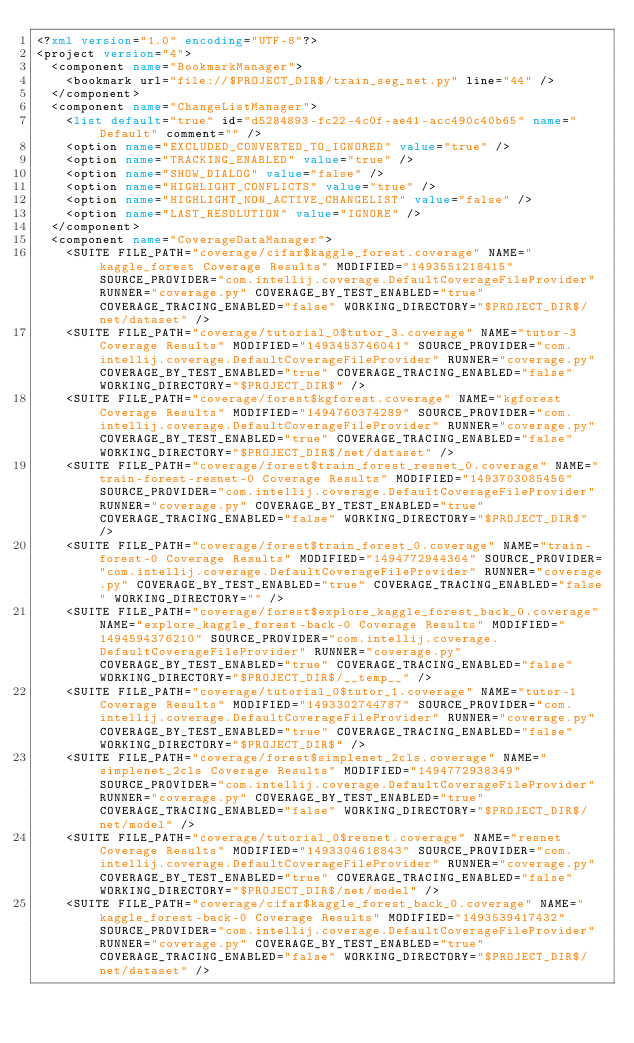<code> <loc_0><loc_0><loc_500><loc_500><_XML_><?xml version="1.0" encoding="UTF-8"?>
<project version="4">
  <component name="BookmarkManager">
    <bookmark url="file://$PROJECT_DIR$/train_seg_net.py" line="44" />
  </component>
  <component name="ChangeListManager">
    <list default="true" id="d5284893-fc22-4c0f-ae41-acc490c40b65" name="Default" comment="" />
    <option name="EXCLUDED_CONVERTED_TO_IGNORED" value="true" />
    <option name="TRACKING_ENABLED" value="true" />
    <option name="SHOW_DIALOG" value="false" />
    <option name="HIGHLIGHT_CONFLICTS" value="true" />
    <option name="HIGHLIGHT_NON_ACTIVE_CHANGELIST" value="false" />
    <option name="LAST_RESOLUTION" value="IGNORE" />
  </component>
  <component name="CoverageDataManager">
    <SUITE FILE_PATH="coverage/cifar$kaggle_forest.coverage" NAME="kaggle_forest Coverage Results" MODIFIED="1493551218415" SOURCE_PROVIDER="com.intellij.coverage.DefaultCoverageFileProvider" RUNNER="coverage.py" COVERAGE_BY_TEST_ENABLED="true" COVERAGE_TRACING_ENABLED="false" WORKING_DIRECTORY="$PROJECT_DIR$/net/dataset" />
    <SUITE FILE_PATH="coverage/tutorial_0$tutor_3.coverage" NAME="tutor-3 Coverage Results" MODIFIED="1493453746041" SOURCE_PROVIDER="com.intellij.coverage.DefaultCoverageFileProvider" RUNNER="coverage.py" COVERAGE_BY_TEST_ENABLED="true" COVERAGE_TRACING_ENABLED="false" WORKING_DIRECTORY="$PROJECT_DIR$" />
    <SUITE FILE_PATH="coverage/forest$kgforest.coverage" NAME="kgforest Coverage Results" MODIFIED="1494760374289" SOURCE_PROVIDER="com.intellij.coverage.DefaultCoverageFileProvider" RUNNER="coverage.py" COVERAGE_BY_TEST_ENABLED="true" COVERAGE_TRACING_ENABLED="false" WORKING_DIRECTORY="$PROJECT_DIR$/net/dataset" />
    <SUITE FILE_PATH="coverage/forest$train_forest_resnet_0.coverage" NAME="train-forest-resnet-0 Coverage Results" MODIFIED="1493703085456" SOURCE_PROVIDER="com.intellij.coverage.DefaultCoverageFileProvider" RUNNER="coverage.py" COVERAGE_BY_TEST_ENABLED="true" COVERAGE_TRACING_ENABLED="false" WORKING_DIRECTORY="$PROJECT_DIR$" />
    <SUITE FILE_PATH="coverage/forest$train_forest_0.coverage" NAME="train-forest-0 Coverage Results" MODIFIED="1494772944364" SOURCE_PROVIDER="com.intellij.coverage.DefaultCoverageFileProvider" RUNNER="coverage.py" COVERAGE_BY_TEST_ENABLED="true" COVERAGE_TRACING_ENABLED="false" WORKING_DIRECTORY="" />
    <SUITE FILE_PATH="coverage/forest$explore_kaggle_forest_back_0.coverage" NAME="explore_kaggle_forest-back-0 Coverage Results" MODIFIED="1494594376210" SOURCE_PROVIDER="com.intellij.coverage.DefaultCoverageFileProvider" RUNNER="coverage.py" COVERAGE_BY_TEST_ENABLED="true" COVERAGE_TRACING_ENABLED="false" WORKING_DIRECTORY="$PROJECT_DIR$/__temp__" />
    <SUITE FILE_PATH="coverage/tutorial_0$tutor_1.coverage" NAME="tutor-1 Coverage Results" MODIFIED="1493302744787" SOURCE_PROVIDER="com.intellij.coverage.DefaultCoverageFileProvider" RUNNER="coverage.py" COVERAGE_BY_TEST_ENABLED="true" COVERAGE_TRACING_ENABLED="false" WORKING_DIRECTORY="$PROJECT_DIR$" />
    <SUITE FILE_PATH="coverage/forest$simplenet_2cls.coverage" NAME="simplenet_2cls Coverage Results" MODIFIED="1494772938349" SOURCE_PROVIDER="com.intellij.coverage.DefaultCoverageFileProvider" RUNNER="coverage.py" COVERAGE_BY_TEST_ENABLED="true" COVERAGE_TRACING_ENABLED="false" WORKING_DIRECTORY="$PROJECT_DIR$/net/model" />
    <SUITE FILE_PATH="coverage/tutorial_0$resnet.coverage" NAME="resnet Coverage Results" MODIFIED="1493304618843" SOURCE_PROVIDER="com.intellij.coverage.DefaultCoverageFileProvider" RUNNER="coverage.py" COVERAGE_BY_TEST_ENABLED="true" COVERAGE_TRACING_ENABLED="false" WORKING_DIRECTORY="$PROJECT_DIR$/net/model" />
    <SUITE FILE_PATH="coverage/cifar$kaggle_forest_back_0.coverage" NAME="kaggle_forest-back-0 Coverage Results" MODIFIED="1493539417432" SOURCE_PROVIDER="com.intellij.coverage.DefaultCoverageFileProvider" RUNNER="coverage.py" COVERAGE_BY_TEST_ENABLED="true" COVERAGE_TRACING_ENABLED="false" WORKING_DIRECTORY="$PROJECT_DIR$/net/dataset" /></code> 